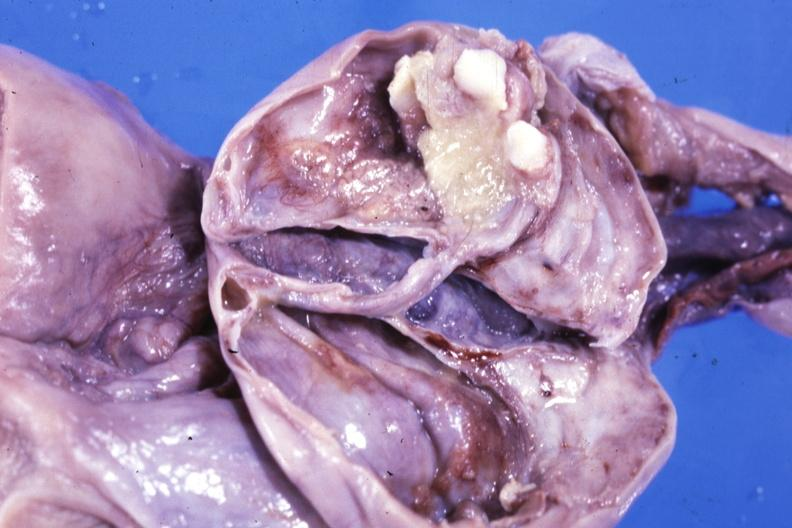s very good example present?
Answer the question using a single word or phrase. No 